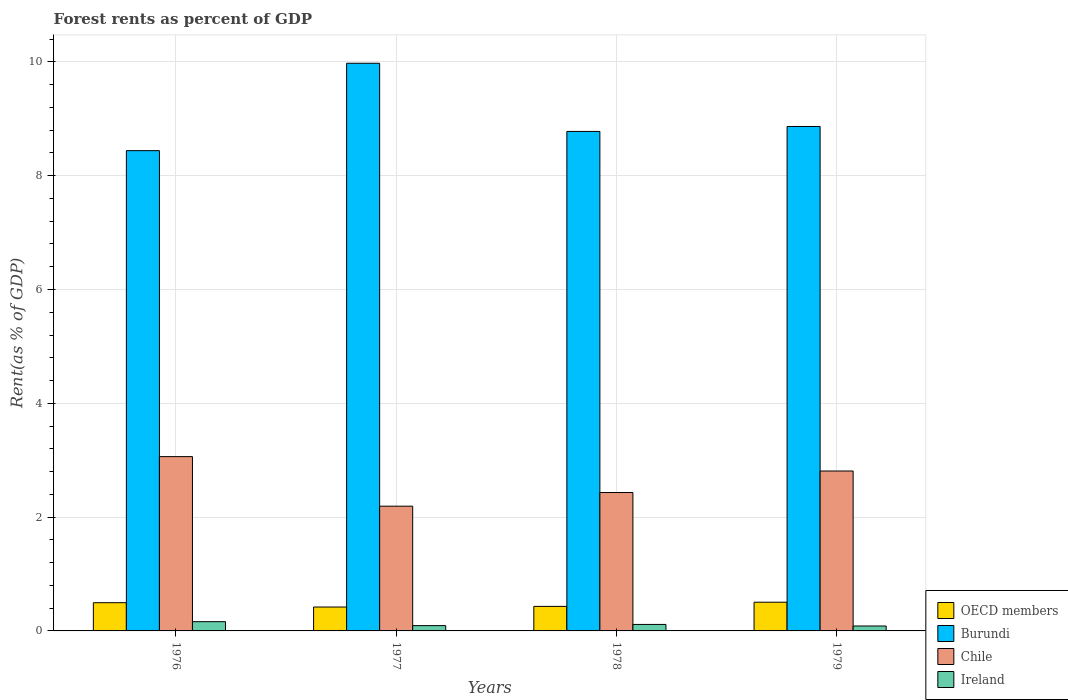Are the number of bars per tick equal to the number of legend labels?
Your answer should be very brief. Yes. Are the number of bars on each tick of the X-axis equal?
Your answer should be very brief. Yes. How many bars are there on the 1st tick from the right?
Your answer should be very brief. 4. What is the label of the 1st group of bars from the left?
Offer a very short reply. 1976. In how many cases, is the number of bars for a given year not equal to the number of legend labels?
Keep it short and to the point. 0. What is the forest rent in Chile in 1976?
Keep it short and to the point. 3.06. Across all years, what is the maximum forest rent in Ireland?
Offer a terse response. 0.16. Across all years, what is the minimum forest rent in Chile?
Provide a succinct answer. 2.19. What is the total forest rent in Burundi in the graph?
Offer a very short reply. 36.06. What is the difference between the forest rent in Chile in 1978 and that in 1979?
Offer a very short reply. -0.38. What is the difference between the forest rent in Burundi in 1976 and the forest rent in OECD members in 1979?
Ensure brevity in your answer.  7.93. What is the average forest rent in OECD members per year?
Offer a terse response. 0.46. In the year 1978, what is the difference between the forest rent in OECD members and forest rent in Chile?
Offer a terse response. -2. In how many years, is the forest rent in Ireland greater than 8 %?
Your response must be concise. 0. What is the ratio of the forest rent in OECD members in 1977 to that in 1978?
Ensure brevity in your answer.  0.97. Is the difference between the forest rent in OECD members in 1976 and 1979 greater than the difference between the forest rent in Chile in 1976 and 1979?
Offer a terse response. No. What is the difference between the highest and the second highest forest rent in Chile?
Provide a short and direct response. 0.25. What is the difference between the highest and the lowest forest rent in OECD members?
Give a very brief answer. 0.08. In how many years, is the forest rent in Ireland greater than the average forest rent in Ireland taken over all years?
Offer a very short reply. 2. Is the sum of the forest rent in OECD members in 1976 and 1978 greater than the maximum forest rent in Burundi across all years?
Make the answer very short. No. What does the 4th bar from the right in 1976 represents?
Provide a succinct answer. OECD members. Is it the case that in every year, the sum of the forest rent in Burundi and forest rent in Chile is greater than the forest rent in OECD members?
Provide a short and direct response. Yes. How many bars are there?
Ensure brevity in your answer.  16. How many years are there in the graph?
Keep it short and to the point. 4. Does the graph contain any zero values?
Provide a short and direct response. No. Does the graph contain grids?
Give a very brief answer. Yes. Where does the legend appear in the graph?
Ensure brevity in your answer.  Bottom right. What is the title of the graph?
Your response must be concise. Forest rents as percent of GDP. What is the label or title of the Y-axis?
Ensure brevity in your answer.  Rent(as % of GDP). What is the Rent(as % of GDP) of OECD members in 1976?
Offer a terse response. 0.5. What is the Rent(as % of GDP) in Burundi in 1976?
Your answer should be compact. 8.44. What is the Rent(as % of GDP) in Chile in 1976?
Your response must be concise. 3.06. What is the Rent(as % of GDP) of Ireland in 1976?
Your answer should be compact. 0.16. What is the Rent(as % of GDP) in OECD members in 1977?
Make the answer very short. 0.42. What is the Rent(as % of GDP) in Burundi in 1977?
Your answer should be compact. 9.98. What is the Rent(as % of GDP) of Chile in 1977?
Ensure brevity in your answer.  2.19. What is the Rent(as % of GDP) of Ireland in 1977?
Ensure brevity in your answer.  0.09. What is the Rent(as % of GDP) in OECD members in 1978?
Make the answer very short. 0.43. What is the Rent(as % of GDP) of Burundi in 1978?
Offer a terse response. 8.78. What is the Rent(as % of GDP) in Chile in 1978?
Make the answer very short. 2.43. What is the Rent(as % of GDP) of Ireland in 1978?
Your answer should be very brief. 0.11. What is the Rent(as % of GDP) of OECD members in 1979?
Make the answer very short. 0.5. What is the Rent(as % of GDP) of Burundi in 1979?
Provide a succinct answer. 8.86. What is the Rent(as % of GDP) in Chile in 1979?
Give a very brief answer. 2.81. What is the Rent(as % of GDP) of Ireland in 1979?
Provide a succinct answer. 0.09. Across all years, what is the maximum Rent(as % of GDP) of OECD members?
Keep it short and to the point. 0.5. Across all years, what is the maximum Rent(as % of GDP) of Burundi?
Your answer should be very brief. 9.98. Across all years, what is the maximum Rent(as % of GDP) of Chile?
Provide a succinct answer. 3.06. Across all years, what is the maximum Rent(as % of GDP) in Ireland?
Offer a terse response. 0.16. Across all years, what is the minimum Rent(as % of GDP) in OECD members?
Give a very brief answer. 0.42. Across all years, what is the minimum Rent(as % of GDP) in Burundi?
Provide a succinct answer. 8.44. Across all years, what is the minimum Rent(as % of GDP) in Chile?
Offer a terse response. 2.19. Across all years, what is the minimum Rent(as % of GDP) in Ireland?
Provide a succinct answer. 0.09. What is the total Rent(as % of GDP) of OECD members in the graph?
Provide a succinct answer. 1.85. What is the total Rent(as % of GDP) in Burundi in the graph?
Ensure brevity in your answer.  36.06. What is the total Rent(as % of GDP) in Chile in the graph?
Provide a short and direct response. 10.5. What is the total Rent(as % of GDP) in Ireland in the graph?
Keep it short and to the point. 0.46. What is the difference between the Rent(as % of GDP) in OECD members in 1976 and that in 1977?
Keep it short and to the point. 0.08. What is the difference between the Rent(as % of GDP) of Burundi in 1976 and that in 1977?
Ensure brevity in your answer.  -1.54. What is the difference between the Rent(as % of GDP) in Chile in 1976 and that in 1977?
Your answer should be compact. 0.87. What is the difference between the Rent(as % of GDP) of Ireland in 1976 and that in 1977?
Your answer should be compact. 0.07. What is the difference between the Rent(as % of GDP) of OECD members in 1976 and that in 1978?
Give a very brief answer. 0.07. What is the difference between the Rent(as % of GDP) in Burundi in 1976 and that in 1978?
Provide a short and direct response. -0.34. What is the difference between the Rent(as % of GDP) of Chile in 1976 and that in 1978?
Make the answer very short. 0.63. What is the difference between the Rent(as % of GDP) in Ireland in 1976 and that in 1978?
Ensure brevity in your answer.  0.05. What is the difference between the Rent(as % of GDP) in OECD members in 1976 and that in 1979?
Ensure brevity in your answer.  -0.01. What is the difference between the Rent(as % of GDP) of Burundi in 1976 and that in 1979?
Keep it short and to the point. -0.42. What is the difference between the Rent(as % of GDP) of Chile in 1976 and that in 1979?
Offer a terse response. 0.25. What is the difference between the Rent(as % of GDP) of Ireland in 1976 and that in 1979?
Your answer should be very brief. 0.08. What is the difference between the Rent(as % of GDP) of OECD members in 1977 and that in 1978?
Ensure brevity in your answer.  -0.01. What is the difference between the Rent(as % of GDP) of Burundi in 1977 and that in 1978?
Offer a terse response. 1.2. What is the difference between the Rent(as % of GDP) of Chile in 1977 and that in 1978?
Ensure brevity in your answer.  -0.24. What is the difference between the Rent(as % of GDP) in Ireland in 1977 and that in 1978?
Ensure brevity in your answer.  -0.02. What is the difference between the Rent(as % of GDP) in OECD members in 1977 and that in 1979?
Keep it short and to the point. -0.08. What is the difference between the Rent(as % of GDP) in Burundi in 1977 and that in 1979?
Your answer should be compact. 1.11. What is the difference between the Rent(as % of GDP) in Chile in 1977 and that in 1979?
Give a very brief answer. -0.62. What is the difference between the Rent(as % of GDP) in Ireland in 1977 and that in 1979?
Offer a terse response. 0.01. What is the difference between the Rent(as % of GDP) in OECD members in 1978 and that in 1979?
Your answer should be very brief. -0.07. What is the difference between the Rent(as % of GDP) of Burundi in 1978 and that in 1979?
Offer a very short reply. -0.09. What is the difference between the Rent(as % of GDP) of Chile in 1978 and that in 1979?
Give a very brief answer. -0.38. What is the difference between the Rent(as % of GDP) of Ireland in 1978 and that in 1979?
Ensure brevity in your answer.  0.03. What is the difference between the Rent(as % of GDP) of OECD members in 1976 and the Rent(as % of GDP) of Burundi in 1977?
Your response must be concise. -9.48. What is the difference between the Rent(as % of GDP) of OECD members in 1976 and the Rent(as % of GDP) of Chile in 1977?
Your response must be concise. -1.7. What is the difference between the Rent(as % of GDP) of OECD members in 1976 and the Rent(as % of GDP) of Ireland in 1977?
Your response must be concise. 0.4. What is the difference between the Rent(as % of GDP) of Burundi in 1976 and the Rent(as % of GDP) of Chile in 1977?
Offer a terse response. 6.25. What is the difference between the Rent(as % of GDP) of Burundi in 1976 and the Rent(as % of GDP) of Ireland in 1977?
Provide a short and direct response. 8.35. What is the difference between the Rent(as % of GDP) in Chile in 1976 and the Rent(as % of GDP) in Ireland in 1977?
Keep it short and to the point. 2.97. What is the difference between the Rent(as % of GDP) in OECD members in 1976 and the Rent(as % of GDP) in Burundi in 1978?
Your answer should be compact. -8.28. What is the difference between the Rent(as % of GDP) of OECD members in 1976 and the Rent(as % of GDP) of Chile in 1978?
Offer a very short reply. -1.94. What is the difference between the Rent(as % of GDP) in OECD members in 1976 and the Rent(as % of GDP) in Ireland in 1978?
Make the answer very short. 0.38. What is the difference between the Rent(as % of GDP) in Burundi in 1976 and the Rent(as % of GDP) in Chile in 1978?
Offer a very short reply. 6.01. What is the difference between the Rent(as % of GDP) in Burundi in 1976 and the Rent(as % of GDP) in Ireland in 1978?
Your answer should be very brief. 8.33. What is the difference between the Rent(as % of GDP) of Chile in 1976 and the Rent(as % of GDP) of Ireland in 1978?
Provide a succinct answer. 2.95. What is the difference between the Rent(as % of GDP) in OECD members in 1976 and the Rent(as % of GDP) in Burundi in 1979?
Your answer should be compact. -8.37. What is the difference between the Rent(as % of GDP) in OECD members in 1976 and the Rent(as % of GDP) in Chile in 1979?
Keep it short and to the point. -2.31. What is the difference between the Rent(as % of GDP) in OECD members in 1976 and the Rent(as % of GDP) in Ireland in 1979?
Ensure brevity in your answer.  0.41. What is the difference between the Rent(as % of GDP) in Burundi in 1976 and the Rent(as % of GDP) in Chile in 1979?
Your answer should be very brief. 5.63. What is the difference between the Rent(as % of GDP) in Burundi in 1976 and the Rent(as % of GDP) in Ireland in 1979?
Offer a very short reply. 8.35. What is the difference between the Rent(as % of GDP) of Chile in 1976 and the Rent(as % of GDP) of Ireland in 1979?
Make the answer very short. 2.98. What is the difference between the Rent(as % of GDP) in OECD members in 1977 and the Rent(as % of GDP) in Burundi in 1978?
Offer a terse response. -8.36. What is the difference between the Rent(as % of GDP) of OECD members in 1977 and the Rent(as % of GDP) of Chile in 1978?
Your response must be concise. -2.01. What is the difference between the Rent(as % of GDP) in OECD members in 1977 and the Rent(as % of GDP) in Ireland in 1978?
Give a very brief answer. 0.31. What is the difference between the Rent(as % of GDP) in Burundi in 1977 and the Rent(as % of GDP) in Chile in 1978?
Your response must be concise. 7.54. What is the difference between the Rent(as % of GDP) in Burundi in 1977 and the Rent(as % of GDP) in Ireland in 1978?
Provide a succinct answer. 9.86. What is the difference between the Rent(as % of GDP) in Chile in 1977 and the Rent(as % of GDP) in Ireland in 1978?
Offer a terse response. 2.08. What is the difference between the Rent(as % of GDP) of OECD members in 1977 and the Rent(as % of GDP) of Burundi in 1979?
Make the answer very short. -8.44. What is the difference between the Rent(as % of GDP) in OECD members in 1977 and the Rent(as % of GDP) in Chile in 1979?
Provide a succinct answer. -2.39. What is the difference between the Rent(as % of GDP) in OECD members in 1977 and the Rent(as % of GDP) in Ireland in 1979?
Ensure brevity in your answer.  0.33. What is the difference between the Rent(as % of GDP) in Burundi in 1977 and the Rent(as % of GDP) in Chile in 1979?
Keep it short and to the point. 7.17. What is the difference between the Rent(as % of GDP) of Burundi in 1977 and the Rent(as % of GDP) of Ireland in 1979?
Your answer should be compact. 9.89. What is the difference between the Rent(as % of GDP) in Chile in 1977 and the Rent(as % of GDP) in Ireland in 1979?
Offer a terse response. 2.11. What is the difference between the Rent(as % of GDP) of OECD members in 1978 and the Rent(as % of GDP) of Burundi in 1979?
Make the answer very short. -8.43. What is the difference between the Rent(as % of GDP) of OECD members in 1978 and the Rent(as % of GDP) of Chile in 1979?
Your response must be concise. -2.38. What is the difference between the Rent(as % of GDP) in OECD members in 1978 and the Rent(as % of GDP) in Ireland in 1979?
Make the answer very short. 0.34. What is the difference between the Rent(as % of GDP) of Burundi in 1978 and the Rent(as % of GDP) of Chile in 1979?
Your answer should be very brief. 5.97. What is the difference between the Rent(as % of GDP) in Burundi in 1978 and the Rent(as % of GDP) in Ireland in 1979?
Ensure brevity in your answer.  8.69. What is the difference between the Rent(as % of GDP) in Chile in 1978 and the Rent(as % of GDP) in Ireland in 1979?
Provide a succinct answer. 2.35. What is the average Rent(as % of GDP) in OECD members per year?
Your response must be concise. 0.46. What is the average Rent(as % of GDP) of Burundi per year?
Provide a short and direct response. 9.01. What is the average Rent(as % of GDP) of Chile per year?
Provide a succinct answer. 2.62. What is the average Rent(as % of GDP) of Ireland per year?
Provide a succinct answer. 0.11. In the year 1976, what is the difference between the Rent(as % of GDP) in OECD members and Rent(as % of GDP) in Burundi?
Provide a succinct answer. -7.94. In the year 1976, what is the difference between the Rent(as % of GDP) in OECD members and Rent(as % of GDP) in Chile?
Keep it short and to the point. -2.57. In the year 1976, what is the difference between the Rent(as % of GDP) in OECD members and Rent(as % of GDP) in Ireland?
Give a very brief answer. 0.33. In the year 1976, what is the difference between the Rent(as % of GDP) of Burundi and Rent(as % of GDP) of Chile?
Give a very brief answer. 5.38. In the year 1976, what is the difference between the Rent(as % of GDP) of Burundi and Rent(as % of GDP) of Ireland?
Your answer should be compact. 8.28. In the year 1976, what is the difference between the Rent(as % of GDP) of Chile and Rent(as % of GDP) of Ireland?
Keep it short and to the point. 2.9. In the year 1977, what is the difference between the Rent(as % of GDP) of OECD members and Rent(as % of GDP) of Burundi?
Your response must be concise. -9.56. In the year 1977, what is the difference between the Rent(as % of GDP) of OECD members and Rent(as % of GDP) of Chile?
Keep it short and to the point. -1.77. In the year 1977, what is the difference between the Rent(as % of GDP) in OECD members and Rent(as % of GDP) in Ireland?
Keep it short and to the point. 0.33. In the year 1977, what is the difference between the Rent(as % of GDP) of Burundi and Rent(as % of GDP) of Chile?
Your answer should be compact. 7.78. In the year 1977, what is the difference between the Rent(as % of GDP) in Burundi and Rent(as % of GDP) in Ireland?
Your response must be concise. 9.88. In the year 1977, what is the difference between the Rent(as % of GDP) in Chile and Rent(as % of GDP) in Ireland?
Make the answer very short. 2.1. In the year 1978, what is the difference between the Rent(as % of GDP) in OECD members and Rent(as % of GDP) in Burundi?
Make the answer very short. -8.35. In the year 1978, what is the difference between the Rent(as % of GDP) of OECD members and Rent(as % of GDP) of Chile?
Your answer should be very brief. -2. In the year 1978, what is the difference between the Rent(as % of GDP) of OECD members and Rent(as % of GDP) of Ireland?
Your answer should be compact. 0.32. In the year 1978, what is the difference between the Rent(as % of GDP) in Burundi and Rent(as % of GDP) in Chile?
Your answer should be compact. 6.35. In the year 1978, what is the difference between the Rent(as % of GDP) of Burundi and Rent(as % of GDP) of Ireland?
Your response must be concise. 8.66. In the year 1978, what is the difference between the Rent(as % of GDP) of Chile and Rent(as % of GDP) of Ireland?
Your answer should be compact. 2.32. In the year 1979, what is the difference between the Rent(as % of GDP) in OECD members and Rent(as % of GDP) in Burundi?
Ensure brevity in your answer.  -8.36. In the year 1979, what is the difference between the Rent(as % of GDP) in OECD members and Rent(as % of GDP) in Chile?
Offer a terse response. -2.31. In the year 1979, what is the difference between the Rent(as % of GDP) in OECD members and Rent(as % of GDP) in Ireland?
Offer a terse response. 0.42. In the year 1979, what is the difference between the Rent(as % of GDP) in Burundi and Rent(as % of GDP) in Chile?
Offer a terse response. 6.05. In the year 1979, what is the difference between the Rent(as % of GDP) of Burundi and Rent(as % of GDP) of Ireland?
Provide a succinct answer. 8.78. In the year 1979, what is the difference between the Rent(as % of GDP) in Chile and Rent(as % of GDP) in Ireland?
Give a very brief answer. 2.72. What is the ratio of the Rent(as % of GDP) of OECD members in 1976 to that in 1977?
Provide a succinct answer. 1.18. What is the ratio of the Rent(as % of GDP) of Burundi in 1976 to that in 1977?
Offer a terse response. 0.85. What is the ratio of the Rent(as % of GDP) of Chile in 1976 to that in 1977?
Provide a short and direct response. 1.4. What is the ratio of the Rent(as % of GDP) of Ireland in 1976 to that in 1977?
Offer a terse response. 1.74. What is the ratio of the Rent(as % of GDP) in OECD members in 1976 to that in 1978?
Provide a short and direct response. 1.15. What is the ratio of the Rent(as % of GDP) of Burundi in 1976 to that in 1978?
Provide a short and direct response. 0.96. What is the ratio of the Rent(as % of GDP) of Chile in 1976 to that in 1978?
Provide a succinct answer. 1.26. What is the ratio of the Rent(as % of GDP) in Ireland in 1976 to that in 1978?
Ensure brevity in your answer.  1.42. What is the ratio of the Rent(as % of GDP) of OECD members in 1976 to that in 1979?
Your response must be concise. 0.98. What is the ratio of the Rent(as % of GDP) of Burundi in 1976 to that in 1979?
Your response must be concise. 0.95. What is the ratio of the Rent(as % of GDP) of Chile in 1976 to that in 1979?
Offer a very short reply. 1.09. What is the ratio of the Rent(as % of GDP) in Ireland in 1976 to that in 1979?
Keep it short and to the point. 1.88. What is the ratio of the Rent(as % of GDP) of Burundi in 1977 to that in 1978?
Your response must be concise. 1.14. What is the ratio of the Rent(as % of GDP) of Chile in 1977 to that in 1978?
Offer a terse response. 0.9. What is the ratio of the Rent(as % of GDP) in Ireland in 1977 to that in 1978?
Offer a terse response. 0.82. What is the ratio of the Rent(as % of GDP) of OECD members in 1977 to that in 1979?
Give a very brief answer. 0.83. What is the ratio of the Rent(as % of GDP) of Burundi in 1977 to that in 1979?
Give a very brief answer. 1.13. What is the ratio of the Rent(as % of GDP) of Chile in 1977 to that in 1979?
Your answer should be compact. 0.78. What is the ratio of the Rent(as % of GDP) of Ireland in 1977 to that in 1979?
Your answer should be compact. 1.08. What is the ratio of the Rent(as % of GDP) in OECD members in 1978 to that in 1979?
Your answer should be compact. 0.85. What is the ratio of the Rent(as % of GDP) in Burundi in 1978 to that in 1979?
Provide a succinct answer. 0.99. What is the ratio of the Rent(as % of GDP) in Chile in 1978 to that in 1979?
Provide a succinct answer. 0.87. What is the ratio of the Rent(as % of GDP) in Ireland in 1978 to that in 1979?
Your response must be concise. 1.32. What is the difference between the highest and the second highest Rent(as % of GDP) in OECD members?
Your response must be concise. 0.01. What is the difference between the highest and the second highest Rent(as % of GDP) in Burundi?
Offer a terse response. 1.11. What is the difference between the highest and the second highest Rent(as % of GDP) in Chile?
Provide a short and direct response. 0.25. What is the difference between the highest and the second highest Rent(as % of GDP) of Ireland?
Your response must be concise. 0.05. What is the difference between the highest and the lowest Rent(as % of GDP) of OECD members?
Provide a succinct answer. 0.08. What is the difference between the highest and the lowest Rent(as % of GDP) in Burundi?
Your response must be concise. 1.54. What is the difference between the highest and the lowest Rent(as % of GDP) of Chile?
Your answer should be very brief. 0.87. What is the difference between the highest and the lowest Rent(as % of GDP) in Ireland?
Your response must be concise. 0.08. 